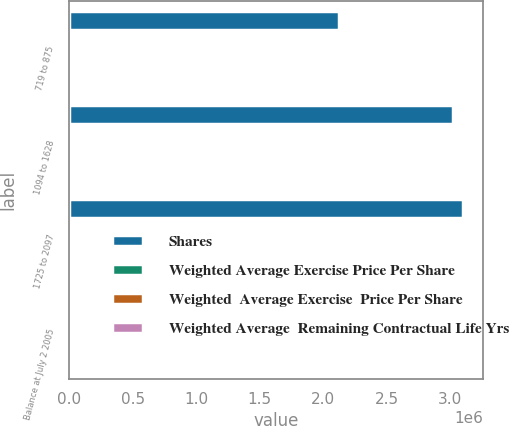<chart> <loc_0><loc_0><loc_500><loc_500><stacked_bar_chart><ecel><fcel>719 to 875<fcel>1094 to 1628<fcel>1725 to 2097<fcel>Balance at July 2 2005<nl><fcel>Shares<fcel>2.12582e+06<fcel>3.02558e+06<fcel>3.10482e+06<fcel>14.52<nl><fcel>Weighted Average Exercise Price Per Share<fcel>8.24<fcel>14.52<fcel>20.86<fcel>15.29<nl><fcel>Weighted  Average Exercise  Price Per Share<fcel>1.54<fcel>3.83<fcel>5.17<fcel>3.71<nl><fcel>Weighted Average  Remaining Contractual Life Yrs<fcel>8.26<fcel>14.49<fcel>20.87<fcel>15.2<nl></chart> 